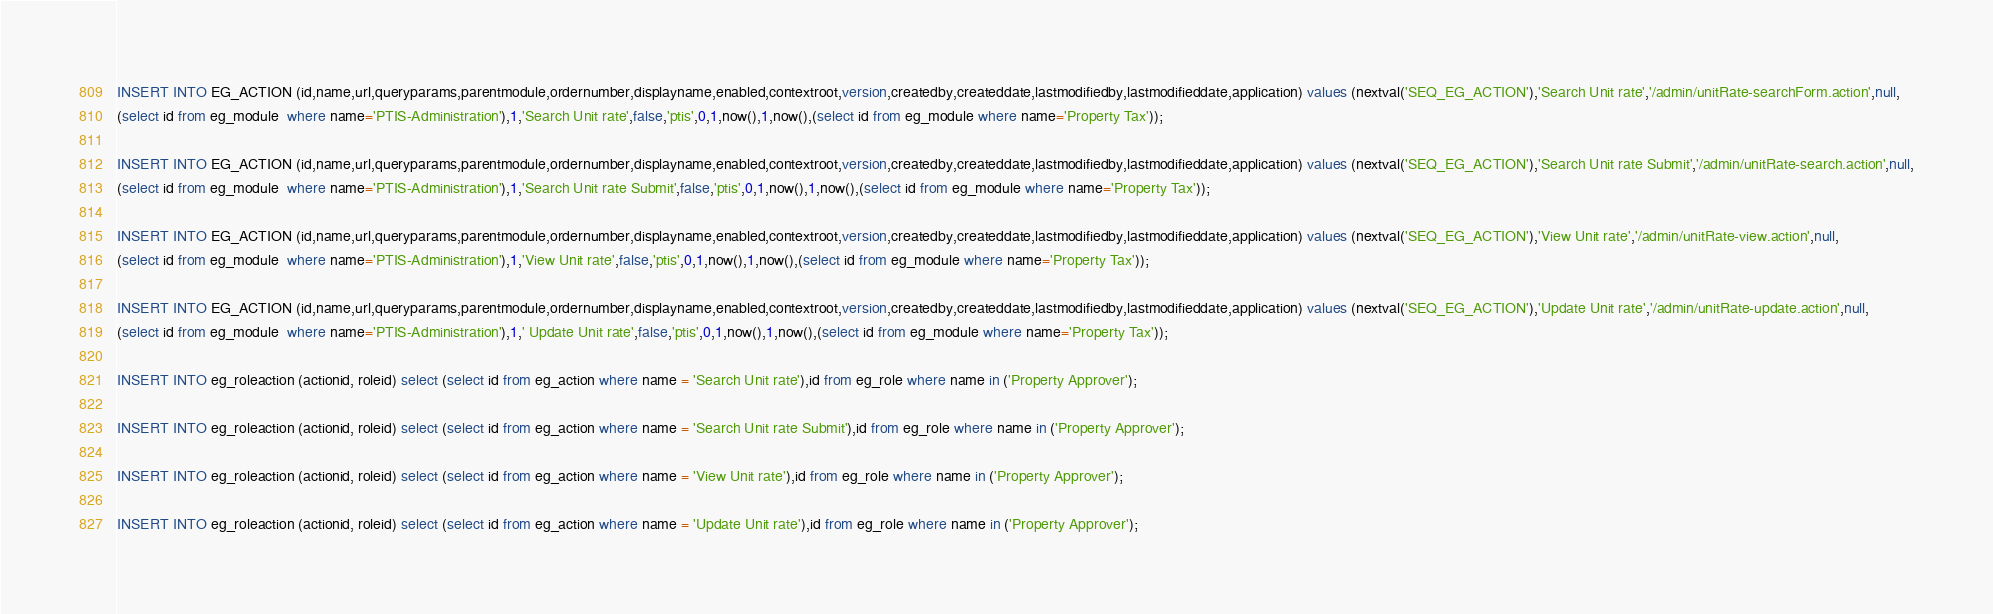<code> <loc_0><loc_0><loc_500><loc_500><_SQL_>INSERT INTO EG_ACTION (id,name,url,queryparams,parentmodule,ordernumber,displayname,enabled,contextroot,version,createdby,createddate,lastmodifiedby,lastmodifieddate,application) values (nextval('SEQ_EG_ACTION'),'Search Unit rate','/admin/unitRate-searchForm.action',null,
(select id from eg_module  where name='PTIS-Administration'),1,'Search Unit rate',false,'ptis',0,1,now(),1,now(),(select id from eg_module where name='Property Tax'));

INSERT INTO EG_ACTION (id,name,url,queryparams,parentmodule,ordernumber,displayname,enabled,contextroot,version,createdby,createddate,lastmodifiedby,lastmodifieddate,application) values (nextval('SEQ_EG_ACTION'),'Search Unit rate Submit','/admin/unitRate-search.action',null,
(select id from eg_module  where name='PTIS-Administration'),1,'Search Unit rate Submit',false,'ptis',0,1,now(),1,now(),(select id from eg_module where name='Property Tax'));

INSERT INTO EG_ACTION (id,name,url,queryparams,parentmodule,ordernumber,displayname,enabled,contextroot,version,createdby,createddate,lastmodifiedby,lastmodifieddate,application) values (nextval('SEQ_EG_ACTION'),'View Unit rate','/admin/unitRate-view.action',null,
(select id from eg_module  where name='PTIS-Administration'),1,'View Unit rate',false,'ptis',0,1,now(),1,now(),(select id from eg_module where name='Property Tax'));

INSERT INTO EG_ACTION (id,name,url,queryparams,parentmodule,ordernumber,displayname,enabled,contextroot,version,createdby,createddate,lastmodifiedby,lastmodifieddate,application) values (nextval('SEQ_EG_ACTION'),'Update Unit rate','/admin/unitRate-update.action',null,
(select id from eg_module  where name='PTIS-Administration'),1,' Update Unit rate',false,'ptis',0,1,now(),1,now(),(select id from eg_module where name='Property Tax'));

INSERT INTO eg_roleaction (actionid, roleid) select (select id from eg_action where name = 'Search Unit rate'),id from eg_role where name in ('Property Approver');

INSERT INTO eg_roleaction (actionid, roleid) select (select id from eg_action where name = 'Search Unit rate Submit'),id from eg_role where name in ('Property Approver');

INSERT INTO eg_roleaction (actionid, roleid) select (select id from eg_action where name = 'View Unit rate'),id from eg_role where name in ('Property Approver');

INSERT INTO eg_roleaction (actionid, roleid) select (select id from eg_action where name = 'Update Unit rate'),id from eg_role where name in ('Property Approver');


</code> 